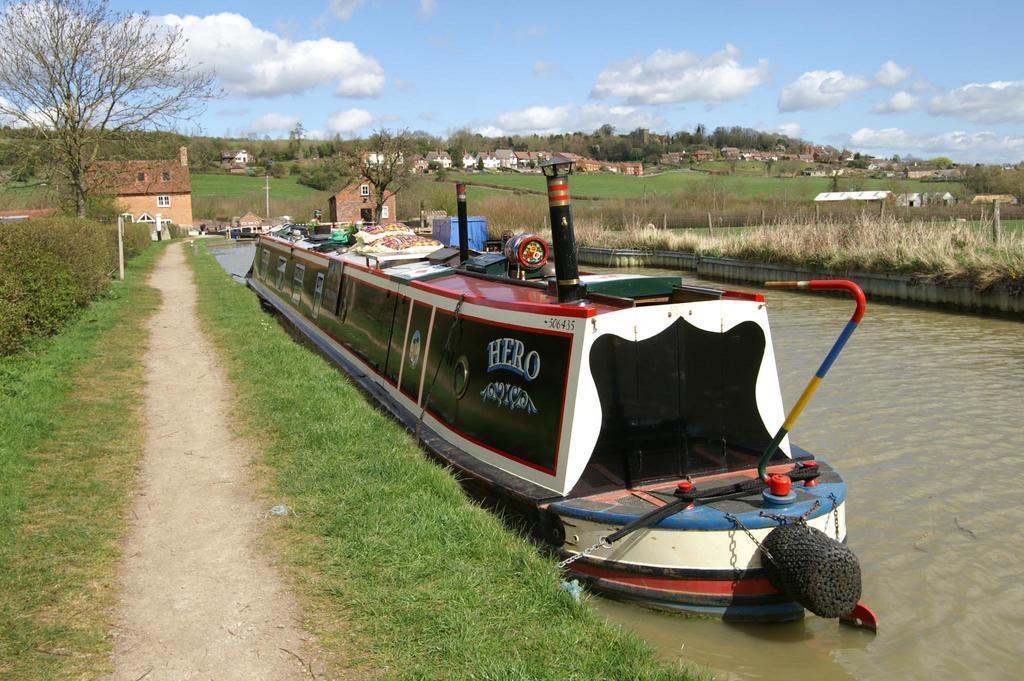In one or two sentences, can you explain what this image depicts? In the image there is a boat in the pond with land on either side of it covered with grass, in the back there are few buildings with trees all over the image and above its sky with clouds. 